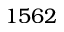<formula> <loc_0><loc_0><loc_500><loc_500>1 5 6 2</formula> 